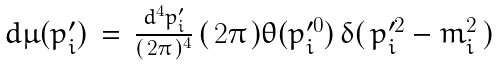Convert formula to latex. <formula><loc_0><loc_0><loc_500><loc_500>\begin{array} { l l l } d \mu ( p _ { i } ^ { \prime } ) \, = \, \frac { d ^ { 4 } p _ { i } ^ { \prime } } { ( \, 2 \pi \, ) ^ { 4 } } \, ( \, 2 \pi \, ) \theta ( p _ { i } ^ { \prime 0 } ) \, \delta ( \, p _ { i } ^ { \prime 2 } - m _ { i } ^ { 2 } \, ) \end{array}</formula> 